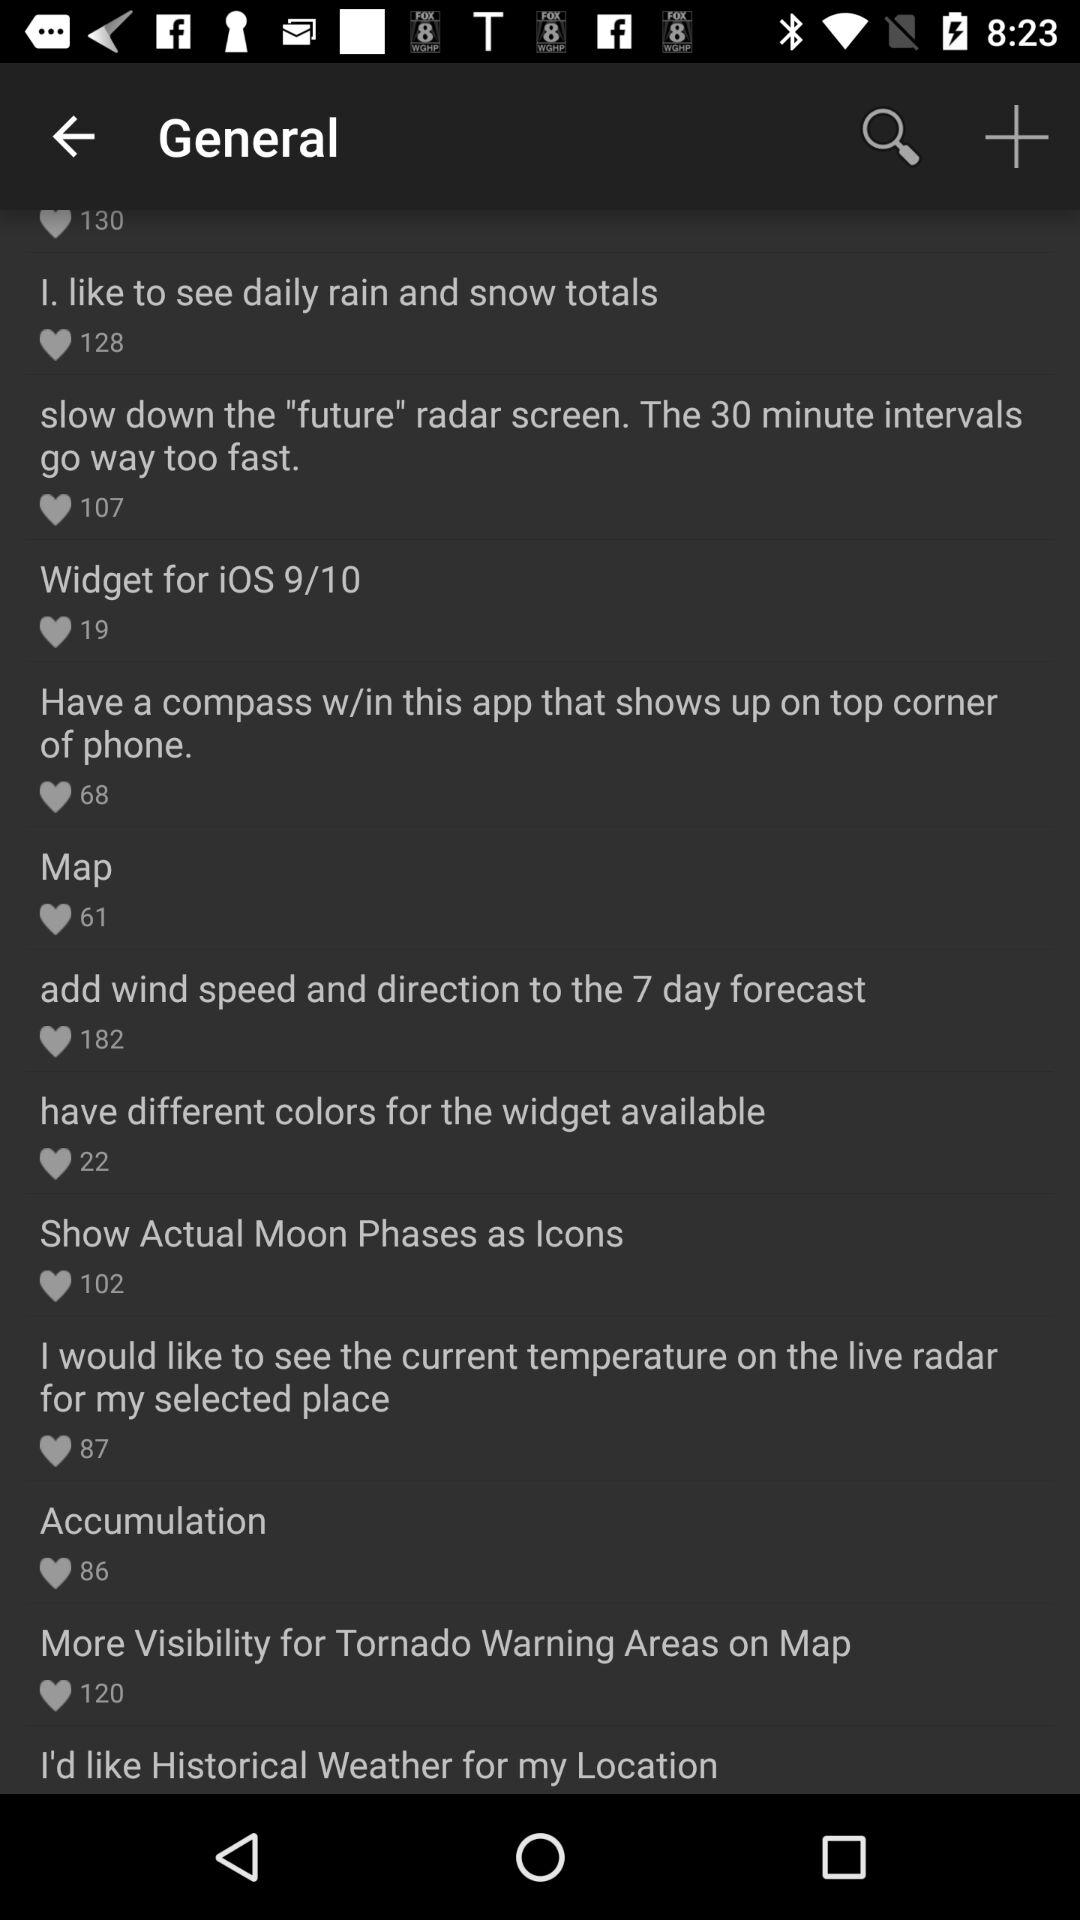How many likes are there on the "Map"? There are 61 likes. 